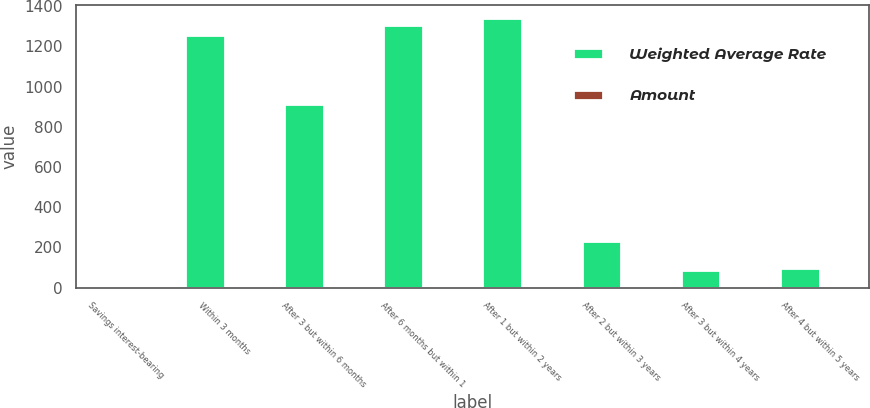<chart> <loc_0><loc_0><loc_500><loc_500><stacked_bar_chart><ecel><fcel>Savings interest-bearing<fcel>Within 3 months<fcel>After 3 but within 6 months<fcel>After 6 months but within 1<fcel>After 1 but within 2 years<fcel>After 2 but within 3 years<fcel>After 3 but within 4 years<fcel>After 4 but within 5 years<nl><fcel>Weighted Average Rate<fcel>1.51<fcel>1254.3<fcel>912.5<fcel>1306.7<fcel>1341<fcel>230.9<fcel>85.5<fcel>96.2<nl><fcel>Amount<fcel>0.19<fcel>0.63<fcel>0.62<fcel>0.79<fcel>1.36<fcel>1.4<fcel>1.07<fcel>1.51<nl></chart> 